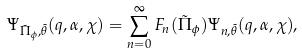<formula> <loc_0><loc_0><loc_500><loc_500>\Psi _ { \tilde { \Pi } _ { \phi } , \tilde { \theta } } ( q , \alpha , \chi ) = \sum _ { n = 0 } ^ { \infty } F _ { n } ( \tilde { \Pi } _ { \phi } ) \Psi _ { n , \tilde { \theta } } ( q , \alpha , \chi ) ,</formula> 